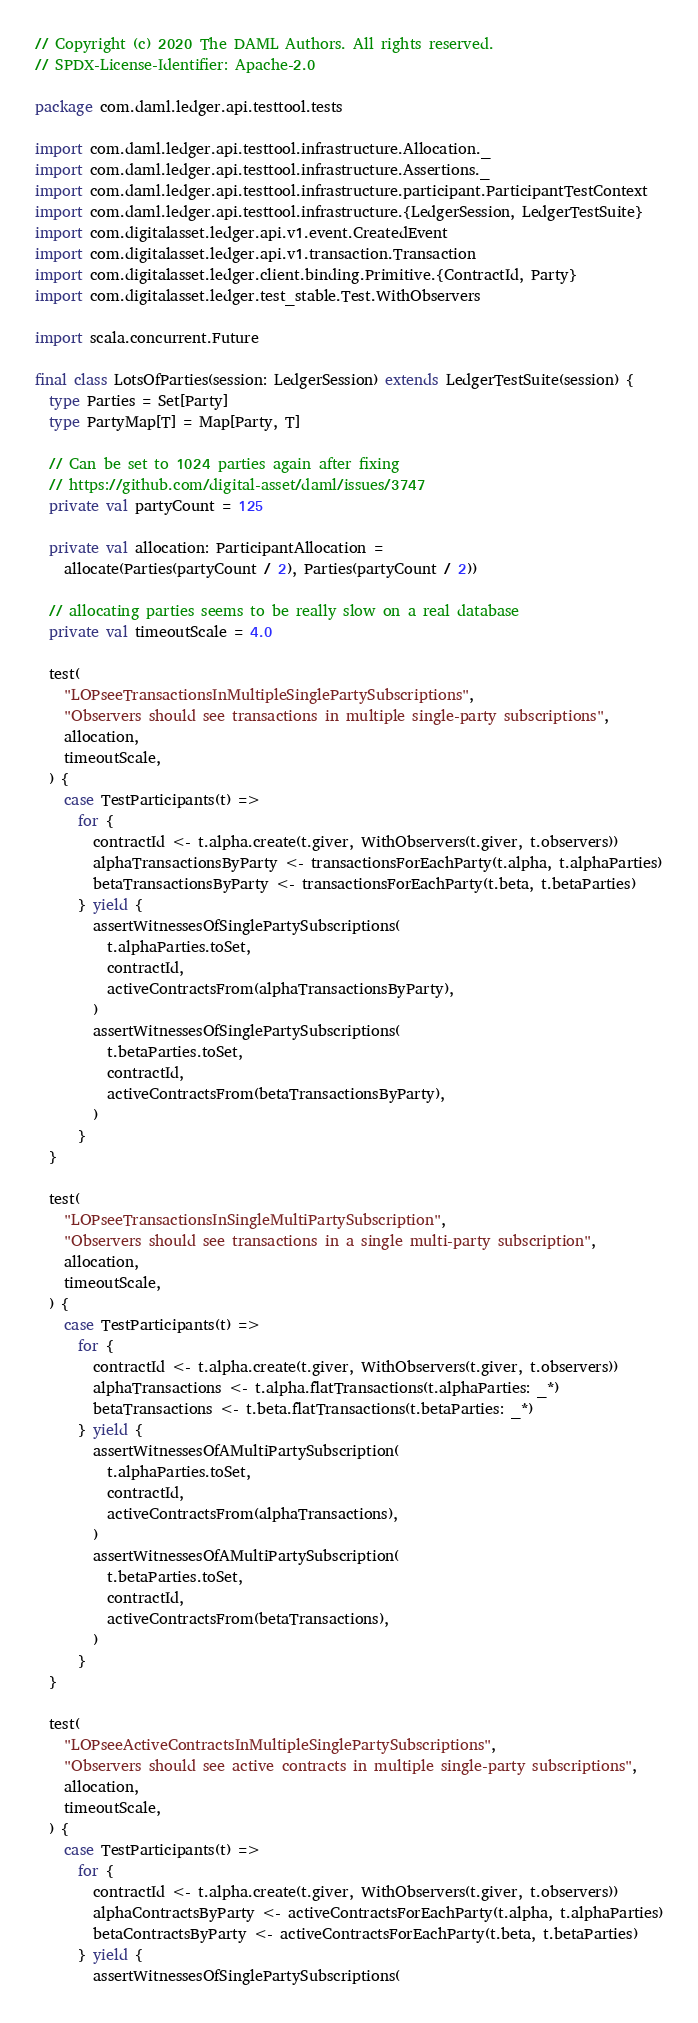Convert code to text. <code><loc_0><loc_0><loc_500><loc_500><_Scala_>// Copyright (c) 2020 The DAML Authors. All rights reserved.
// SPDX-License-Identifier: Apache-2.0

package com.daml.ledger.api.testtool.tests

import com.daml.ledger.api.testtool.infrastructure.Allocation._
import com.daml.ledger.api.testtool.infrastructure.Assertions._
import com.daml.ledger.api.testtool.infrastructure.participant.ParticipantTestContext
import com.daml.ledger.api.testtool.infrastructure.{LedgerSession, LedgerTestSuite}
import com.digitalasset.ledger.api.v1.event.CreatedEvent
import com.digitalasset.ledger.api.v1.transaction.Transaction
import com.digitalasset.ledger.client.binding.Primitive.{ContractId, Party}
import com.digitalasset.ledger.test_stable.Test.WithObservers

import scala.concurrent.Future

final class LotsOfParties(session: LedgerSession) extends LedgerTestSuite(session) {
  type Parties = Set[Party]
  type PartyMap[T] = Map[Party, T]

  // Can be set to 1024 parties again after fixing
  // https://github.com/digital-asset/daml/issues/3747
  private val partyCount = 125

  private val allocation: ParticipantAllocation =
    allocate(Parties(partyCount / 2), Parties(partyCount / 2))

  // allocating parties seems to be really slow on a real database
  private val timeoutScale = 4.0

  test(
    "LOPseeTransactionsInMultipleSinglePartySubscriptions",
    "Observers should see transactions in multiple single-party subscriptions",
    allocation,
    timeoutScale,
  ) {
    case TestParticipants(t) =>
      for {
        contractId <- t.alpha.create(t.giver, WithObservers(t.giver, t.observers))
        alphaTransactionsByParty <- transactionsForEachParty(t.alpha, t.alphaParties)
        betaTransactionsByParty <- transactionsForEachParty(t.beta, t.betaParties)
      } yield {
        assertWitnessesOfSinglePartySubscriptions(
          t.alphaParties.toSet,
          contractId,
          activeContractsFrom(alphaTransactionsByParty),
        )
        assertWitnessesOfSinglePartySubscriptions(
          t.betaParties.toSet,
          contractId,
          activeContractsFrom(betaTransactionsByParty),
        )
      }
  }

  test(
    "LOPseeTransactionsInSingleMultiPartySubscription",
    "Observers should see transactions in a single multi-party subscription",
    allocation,
    timeoutScale,
  ) {
    case TestParticipants(t) =>
      for {
        contractId <- t.alpha.create(t.giver, WithObservers(t.giver, t.observers))
        alphaTransactions <- t.alpha.flatTransactions(t.alphaParties: _*)
        betaTransactions <- t.beta.flatTransactions(t.betaParties: _*)
      } yield {
        assertWitnessesOfAMultiPartySubscription(
          t.alphaParties.toSet,
          contractId,
          activeContractsFrom(alphaTransactions),
        )
        assertWitnessesOfAMultiPartySubscription(
          t.betaParties.toSet,
          contractId,
          activeContractsFrom(betaTransactions),
        )
      }
  }

  test(
    "LOPseeActiveContractsInMultipleSinglePartySubscriptions",
    "Observers should see active contracts in multiple single-party subscriptions",
    allocation,
    timeoutScale,
  ) {
    case TestParticipants(t) =>
      for {
        contractId <- t.alpha.create(t.giver, WithObservers(t.giver, t.observers))
        alphaContractsByParty <- activeContractsForEachParty(t.alpha, t.alphaParties)
        betaContractsByParty <- activeContractsForEachParty(t.beta, t.betaParties)
      } yield {
        assertWitnessesOfSinglePartySubscriptions(</code> 